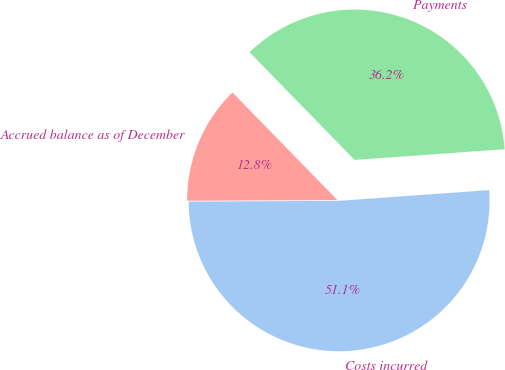Convert chart. <chart><loc_0><loc_0><loc_500><loc_500><pie_chart><fcel>Costs incurred<fcel>Payments<fcel>Accrued balance as of December<nl><fcel>51.06%<fcel>36.17%<fcel>12.77%<nl></chart> 